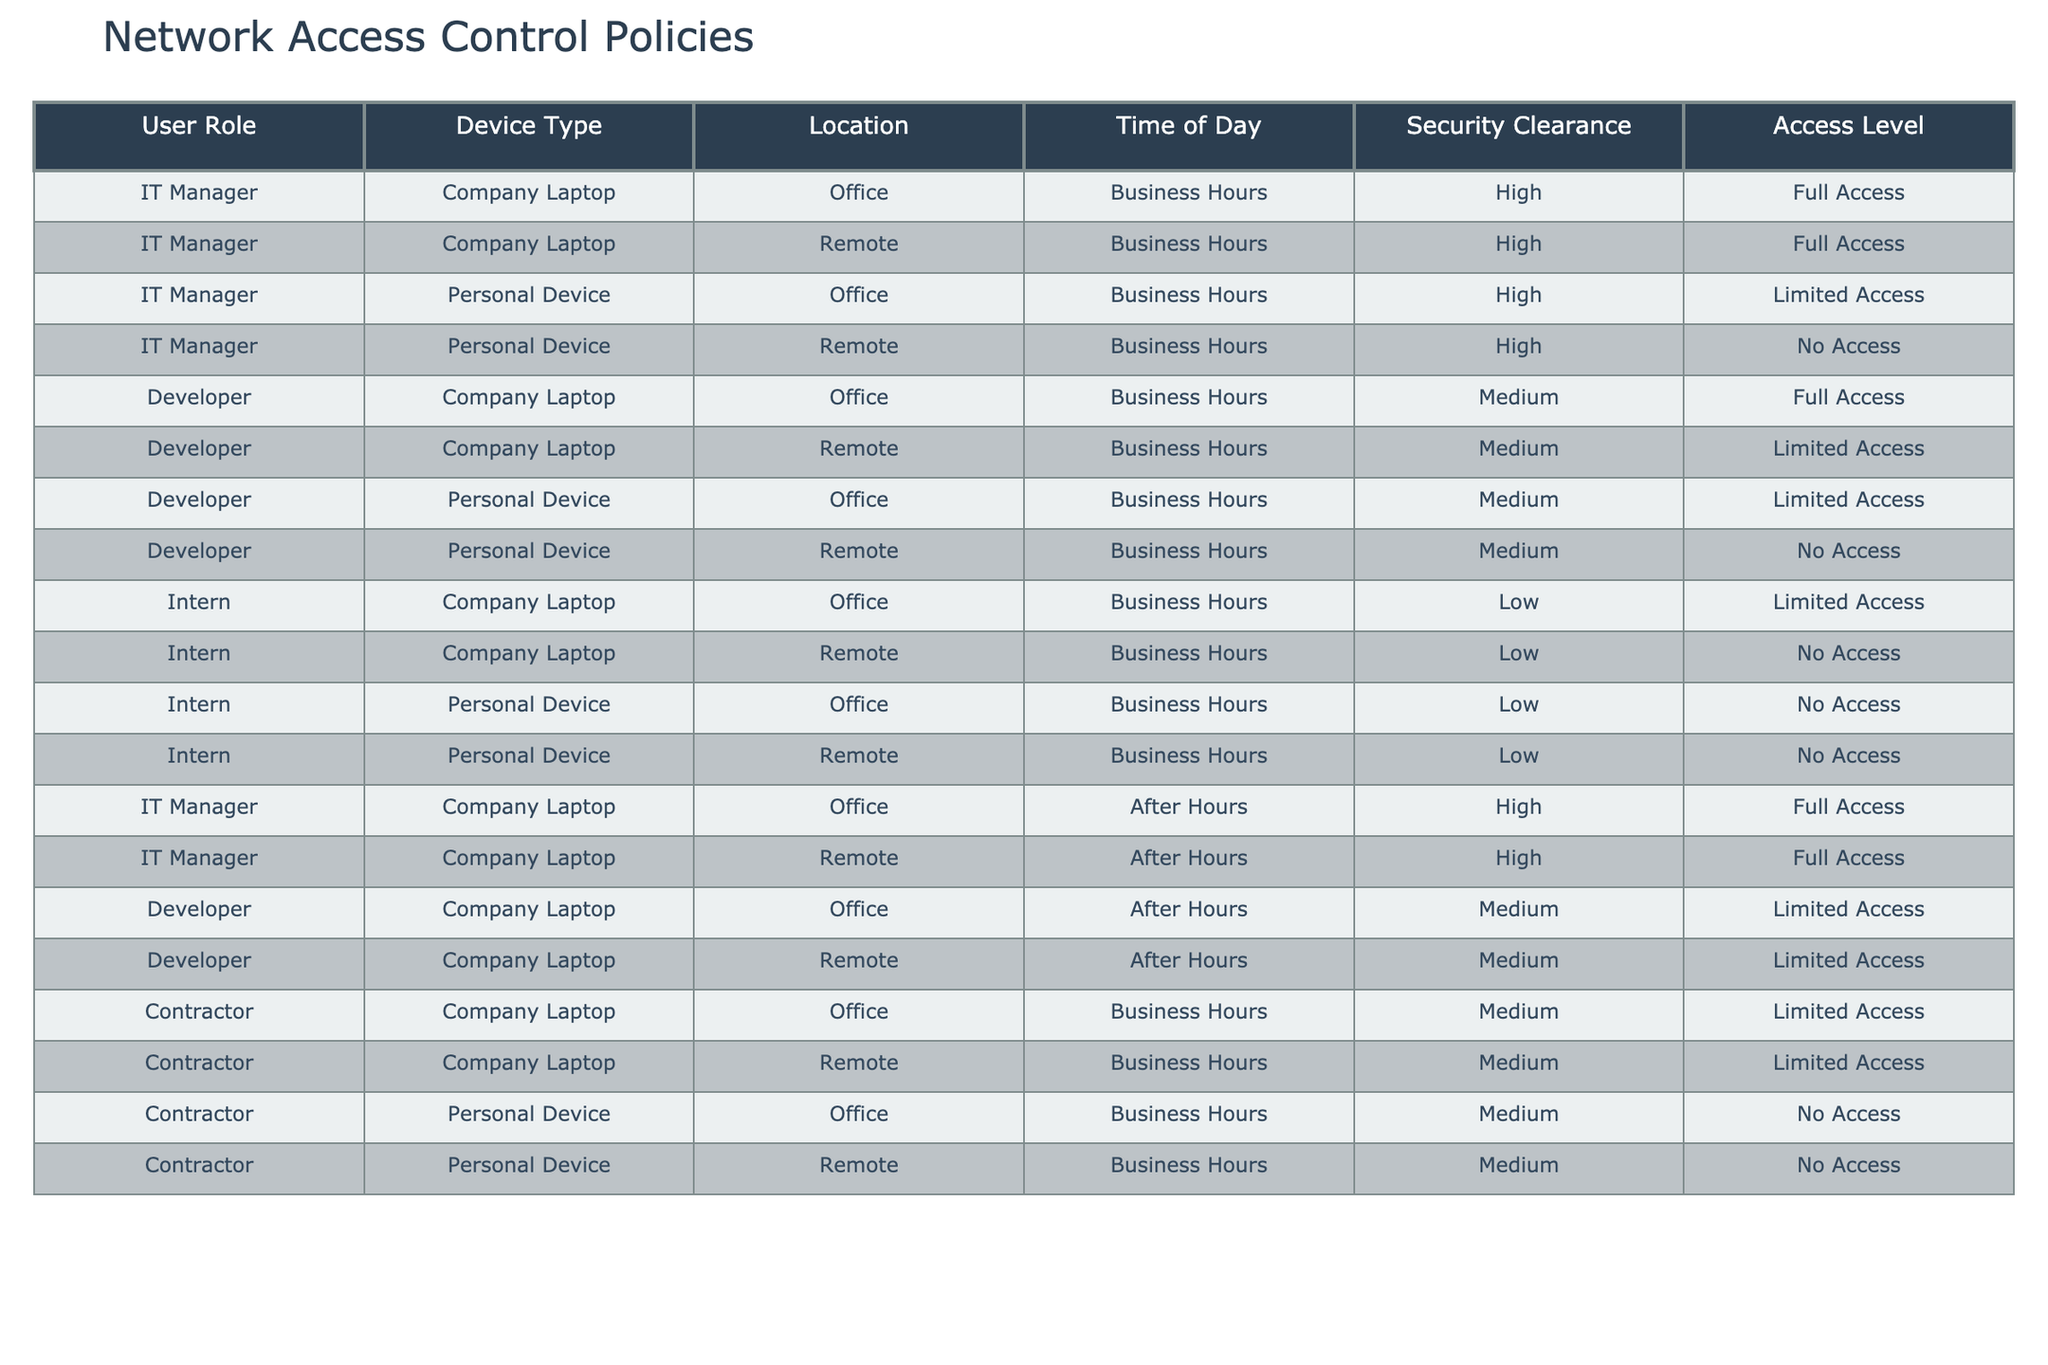What access level does an IT Manager have when using a company laptop in the office during business hours? According to the table, the IT Manager has 'Full Access' while using a company laptop in the office during business hours, as indicated in the corresponding row.
Answer: Full Access Is a Developer allowed to use a personal device in the office during business hours? The table shows that a Developer using a personal device in the office during business hours has 'Limited Access', which means they are permitted to use it but with some restrictions.
Answer: Yes How many user roles have full access in the office during business hours? Scanning through the table, the user roles with 'Full Access' in the office during business hours are the IT Manager and the Developer. Therefore, there are 2 roles with full access.
Answer: 2 Does an Intern have access to a personal device at any time? The table indicates that the Intern has 'No Access' when using a personal device both in the office and remotely during business hours. Therefore, the answer is no, as they are restricted at all times.
Answer: No What is the access level for a Contractor using a personal device during business hours? According to the table, the Contractor has 'No Access' while using a personal device during business hours, as specified in the relevant rows.
Answer: No Access What is the total number of access levels for Developers when using a company laptop during both business hours and after hours? The table outlines that Developers have 'Full Access' during business hours and 'Limited Access' after hours while using a company laptop. Therefore, the total access levels are a combination of both, which includes full and limited, indicating that the Developer's access changes based on time.
Answer: 2 (Full, Limited) How does security clearance affect access level for an IT Manager working remotely after hours? The table indicates that an IT Manager working remotely after hours maintains 'Full Access', showing that despite the time, their high security clearance ensures they retain the same access level.
Answer: Full Access What are the differences in access level for Interns based on device type? Analyzing the table reveals that Interns using a company laptop in the office have 'Limited Access', but when using a personal device, they have 'No Access' regardless of location. This shows a significant reduction in access when using personal devices.
Answer: Limited Access vs. No Access Is it true that all user roles can access their company laptops after hours? Reviewing the table, it shows that while the IT Manager and Developer can access their company laptops after hours, the Intern does not have access at that time. Therefore, the statement is false, as not all user roles have access.
Answer: No 